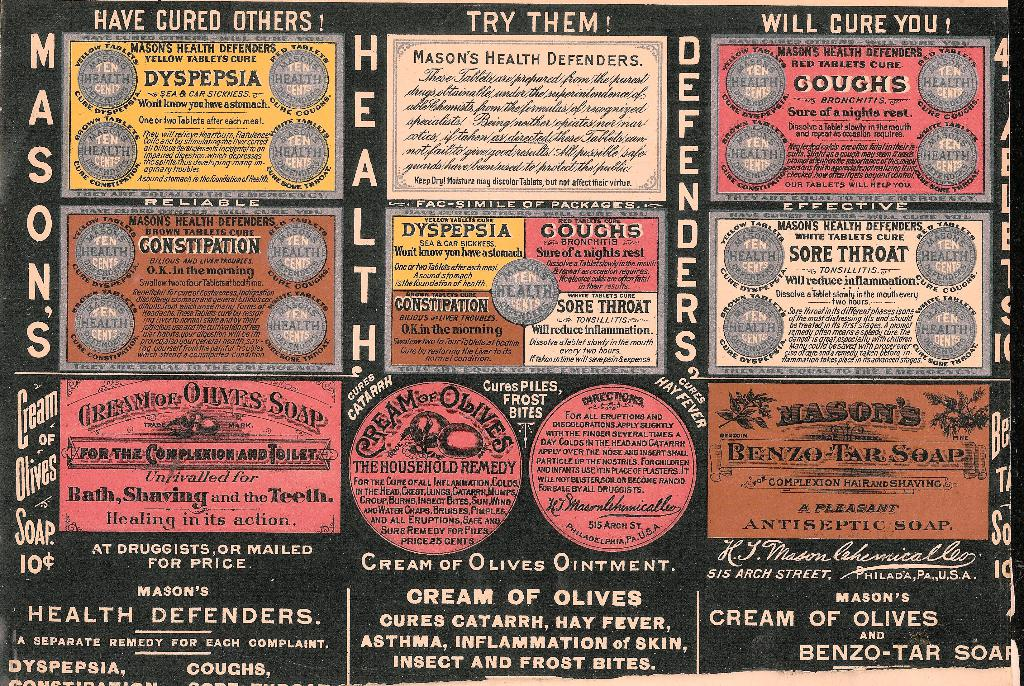Can you identify any unique selling propositions from the image? The image highlights that each remedy is a 'Separate Remedy for Each Complaint', emphasizing the specialized nature of the products. Additionally, it mentions the use of Yellow Tablets for dyspepsia, and the red tablets for coughs, suggesting a targeted approach to treatment. What can you infer about the marketing strategies used in this advertisement? The marketing strategy includes strong, confident claims such as 'Have Cured Others! Will Cure You!' suggesting efficacy and encouraging trials. Testimonials, guarantees, and appeal to quick relief are also visible. Additionally, the products are marketed for convenience, available at druggists or by mail, and the advertisement promotes a diverse range of products from tablets to soaps, catering to various consumer needs. 